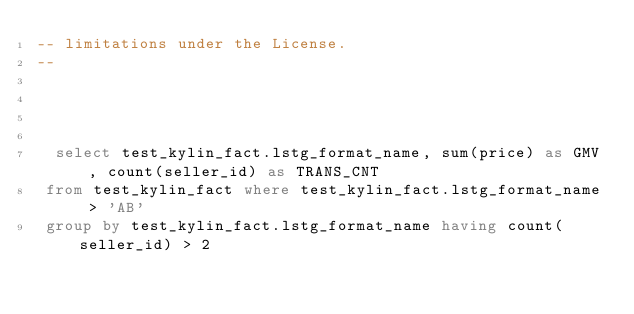<code> <loc_0><loc_0><loc_500><loc_500><_SQL_>-- limitations under the License.
--


 
 
  select test_kylin_fact.lstg_format_name, sum(price) as GMV, count(seller_id) as TRANS_CNT 
 from test_kylin_fact where test_kylin_fact.lstg_format_name > 'AB' 
 group by test_kylin_fact.lstg_format_name having count(seller_id) > 2 
</code> 